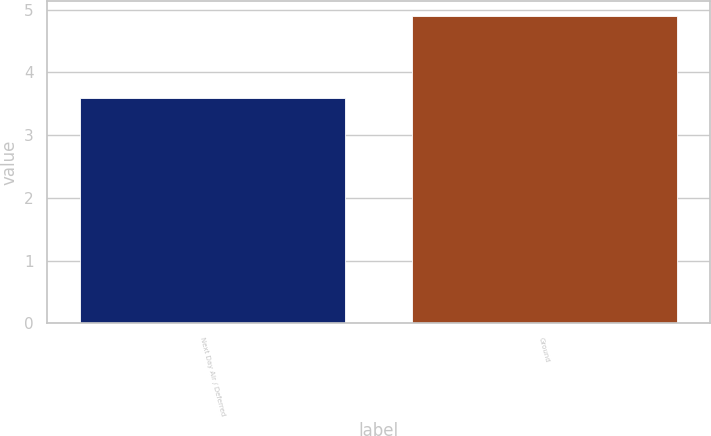Convert chart. <chart><loc_0><loc_0><loc_500><loc_500><bar_chart><fcel>Next Day Air / Deferred<fcel>Ground<nl><fcel>3.6<fcel>4.9<nl></chart> 